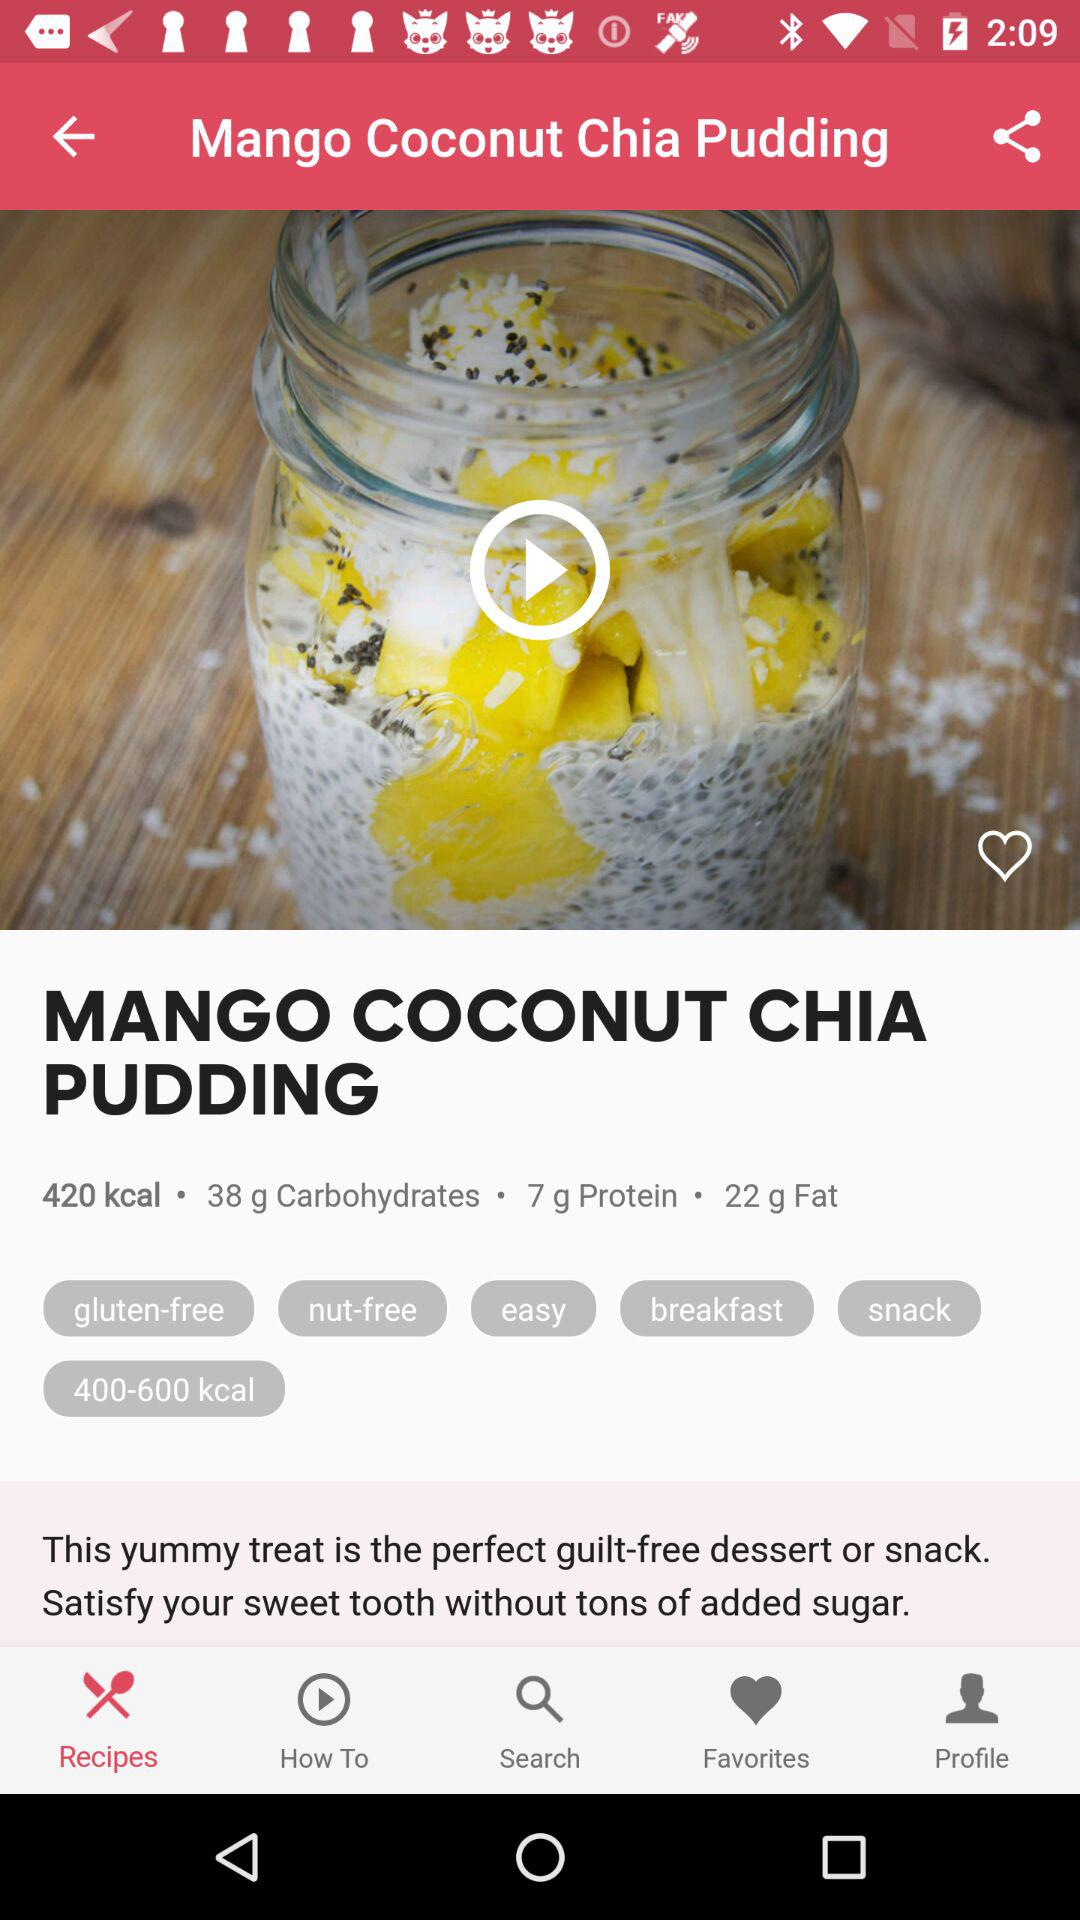How many carbohydrates are there in mango coconut chia pudding? There are 38 grams of carbohydrates. 